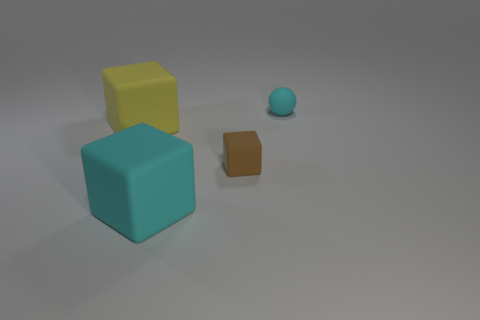Add 4 tiny matte spheres. How many objects exist? 8 Subtract all big cubes. How many cubes are left? 1 Subtract all cyan cubes. How many cubes are left? 2 Subtract 1 cubes. How many cubes are left? 2 Subtract all blocks. How many objects are left? 1 Add 2 big yellow matte things. How many big yellow matte things exist? 3 Subtract 1 cyan spheres. How many objects are left? 3 Subtract all cyan blocks. Subtract all gray spheres. How many blocks are left? 2 Subtract all brown cylinders. How many brown cubes are left? 1 Subtract all small red matte cylinders. Subtract all matte objects. How many objects are left? 0 